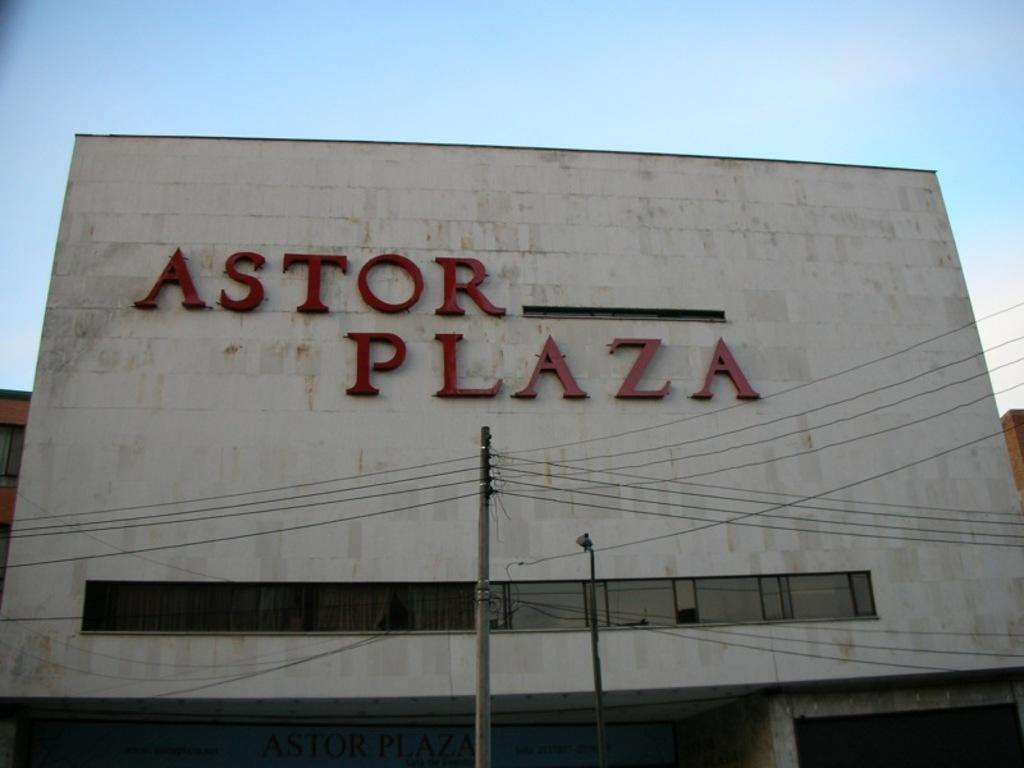What type of structure is present in the image? There is a building in the image. What can be seen on the building? The building has letters on it. What objects are in the foreground of the image? There are poles with cables in the foreground of the image. What is visible in the background of the image? The sky is visible in the background of the image. Can you see a spy eating lunch in the building's lunchroom in the image? There is no indication of a spy or a lunchroom in the image; it only shows a building with letters on it, poles with cables in the foreground, and the sky visible in the background. Is there a wren perched on the building's roof in the image? There is no wren present in the image. 